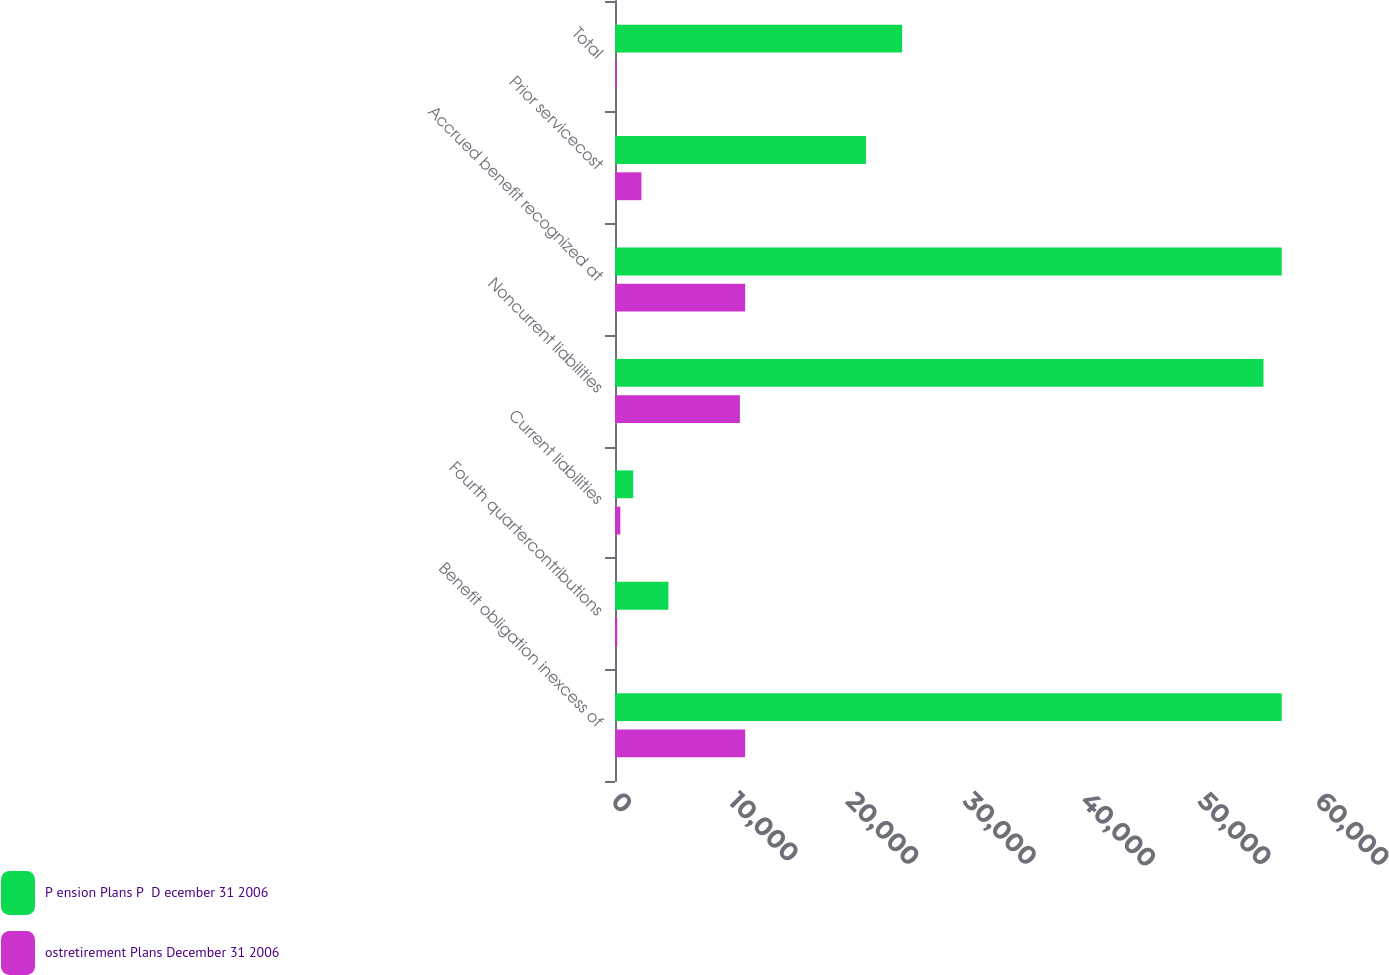<chart> <loc_0><loc_0><loc_500><loc_500><stacked_bar_chart><ecel><fcel>Benefit obligation inexcess of<fcel>Fourth quartercontributions<fcel>Current liabilities<fcel>Noncurrent liabilities<fcel>Accrued benefit recognized at<fcel>Prior servicecost<fcel>Total<nl><fcel>P ension Plans P  D ecember 31 2006<fcel>56822<fcel>4552<fcel>1553<fcel>55269<fcel>56822<fcel>21387<fcel>24471<nl><fcel>ostretirement Plans December 31 2006<fcel>11096<fcel>192<fcel>451<fcel>10645<fcel>11096<fcel>2254<fcel>136<nl></chart> 